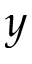Convert formula to latex. <formula><loc_0><loc_0><loc_500><loc_500>y</formula> 